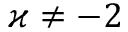<formula> <loc_0><loc_0><loc_500><loc_500>\varkappa \neq - 2</formula> 